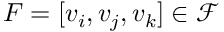<formula> <loc_0><loc_0><loc_500><loc_500>F = [ v _ { i } , v _ { j } , v _ { k } ] \in \mathcal { F }</formula> 